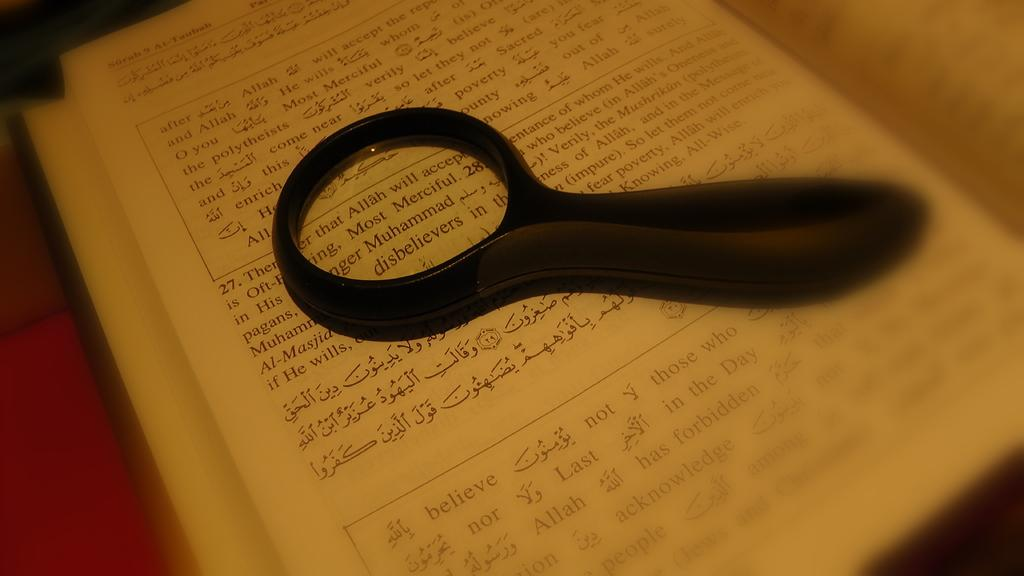<image>
Summarize the visual content of the image. A magnifying glass is on top of text about Muhammad. 